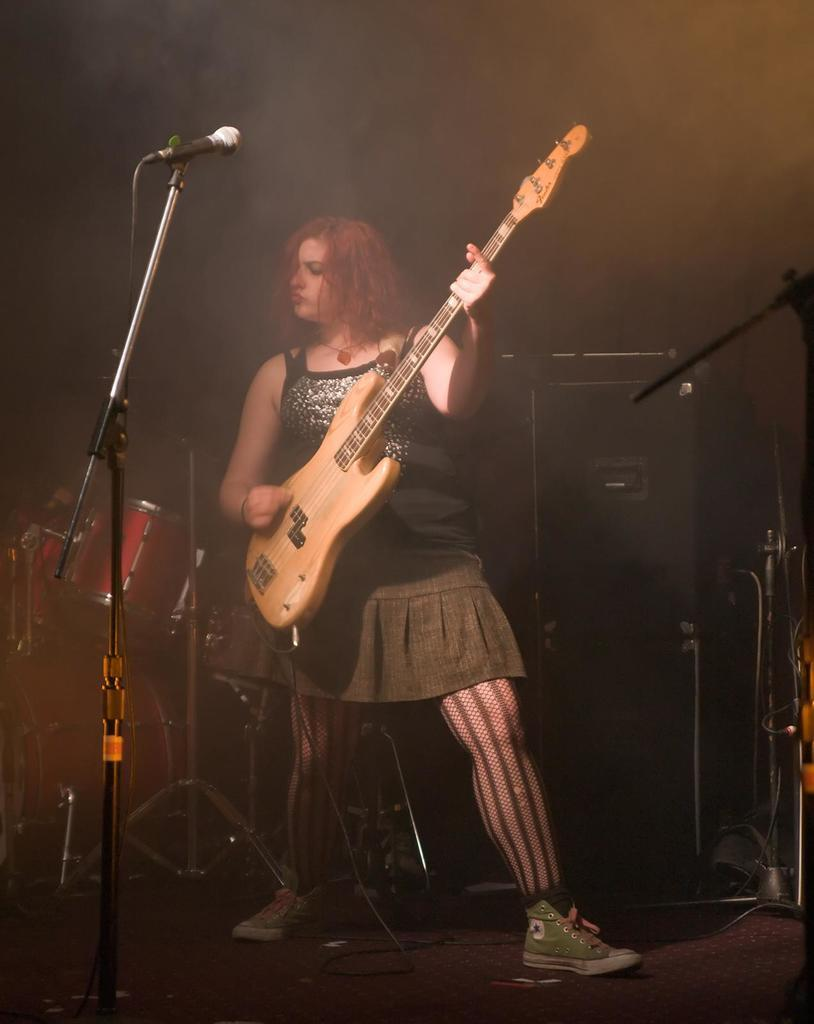What is the main subject of the image? There is a woman in the image. What is the woman doing in the image? The woman is standing and holding a guitar. What is the woman wearing in the image? The woman is wearing a black top. What can be seen in the background of the image? There is a microphone and a drum set in the background. What type of nail is the woman hammering into the scarecrow in the image? There is no nail or scarecrow present in the image. What color is the flag that the woman is holding in the image? There is no flag present in the image. 